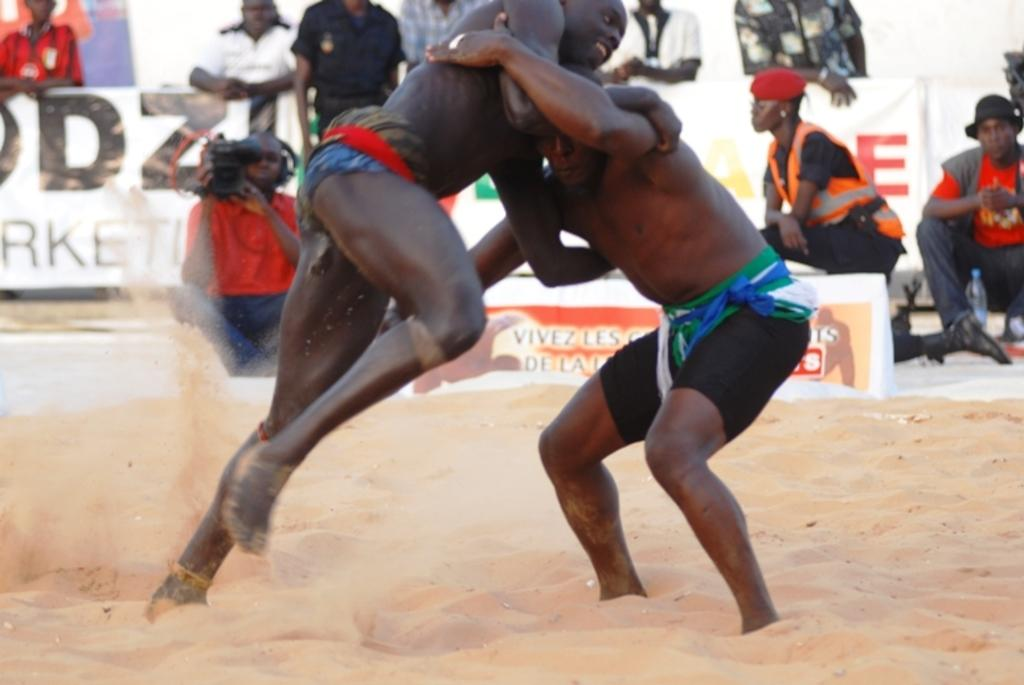What are the two persons in the image doing? The two persons in the image are fighting. What is the surface on which the fighting is taking place? The fighting is taking place on sand. Can you describe the person in the background of the image? There is a person holding a camera in the background of the image. What else can be seen in the background of the image? There is a group of persons and boards visible in the background of the image. What type of jellyfish can be seen swimming in the water near the fighting persons? There is no water or jellyfish present in the image; the fighting is taking place on sand. Can you describe the branch that the persons are using as a weapon during the fight? There is no branch or weapon mentioned in the image; the persons are fighting without any visible objects. 